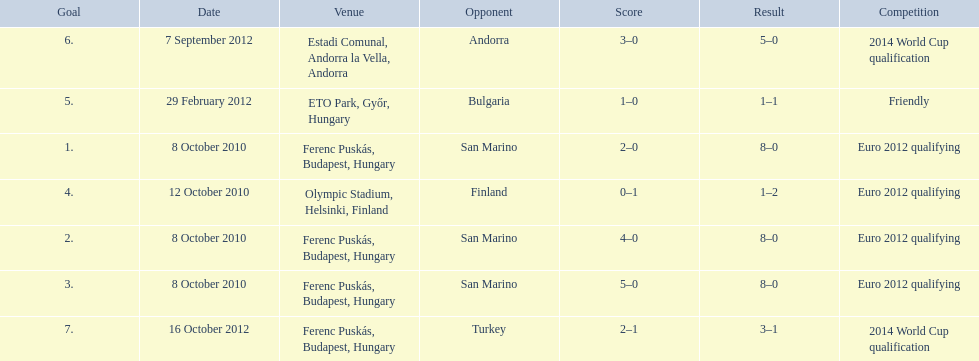How many goals were scored at the euro 2012 qualifying competition? 12. 